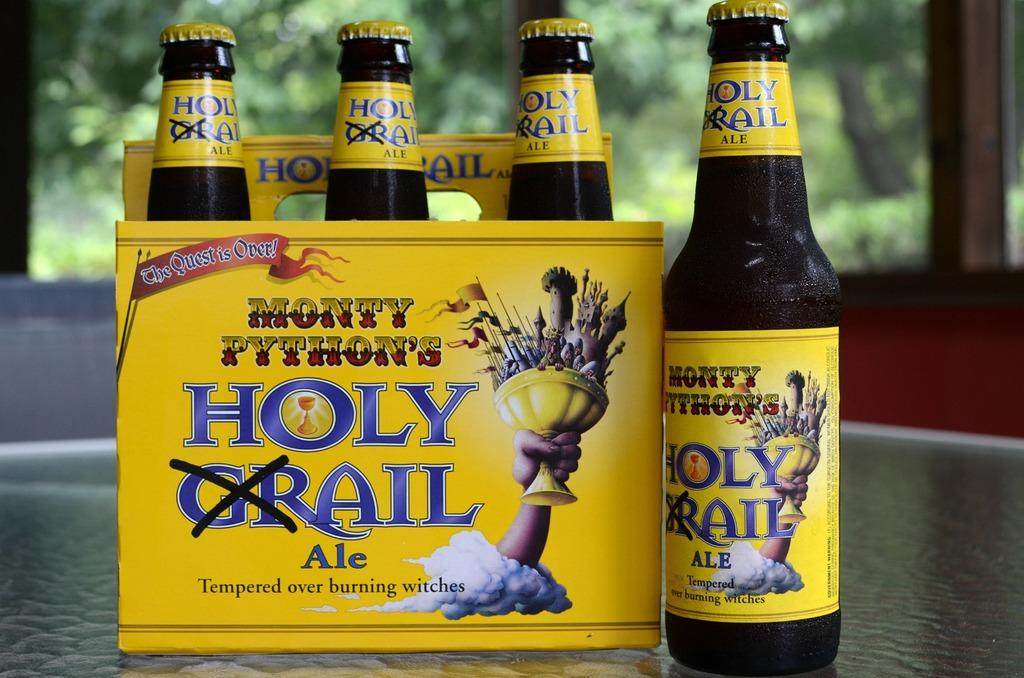<image>
Share a concise interpretation of the image provided. A six pack of Monty Python's holy grail ale on a glass table. 